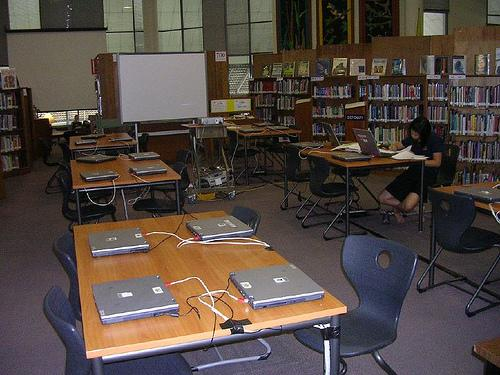Who owns those laptops? school 